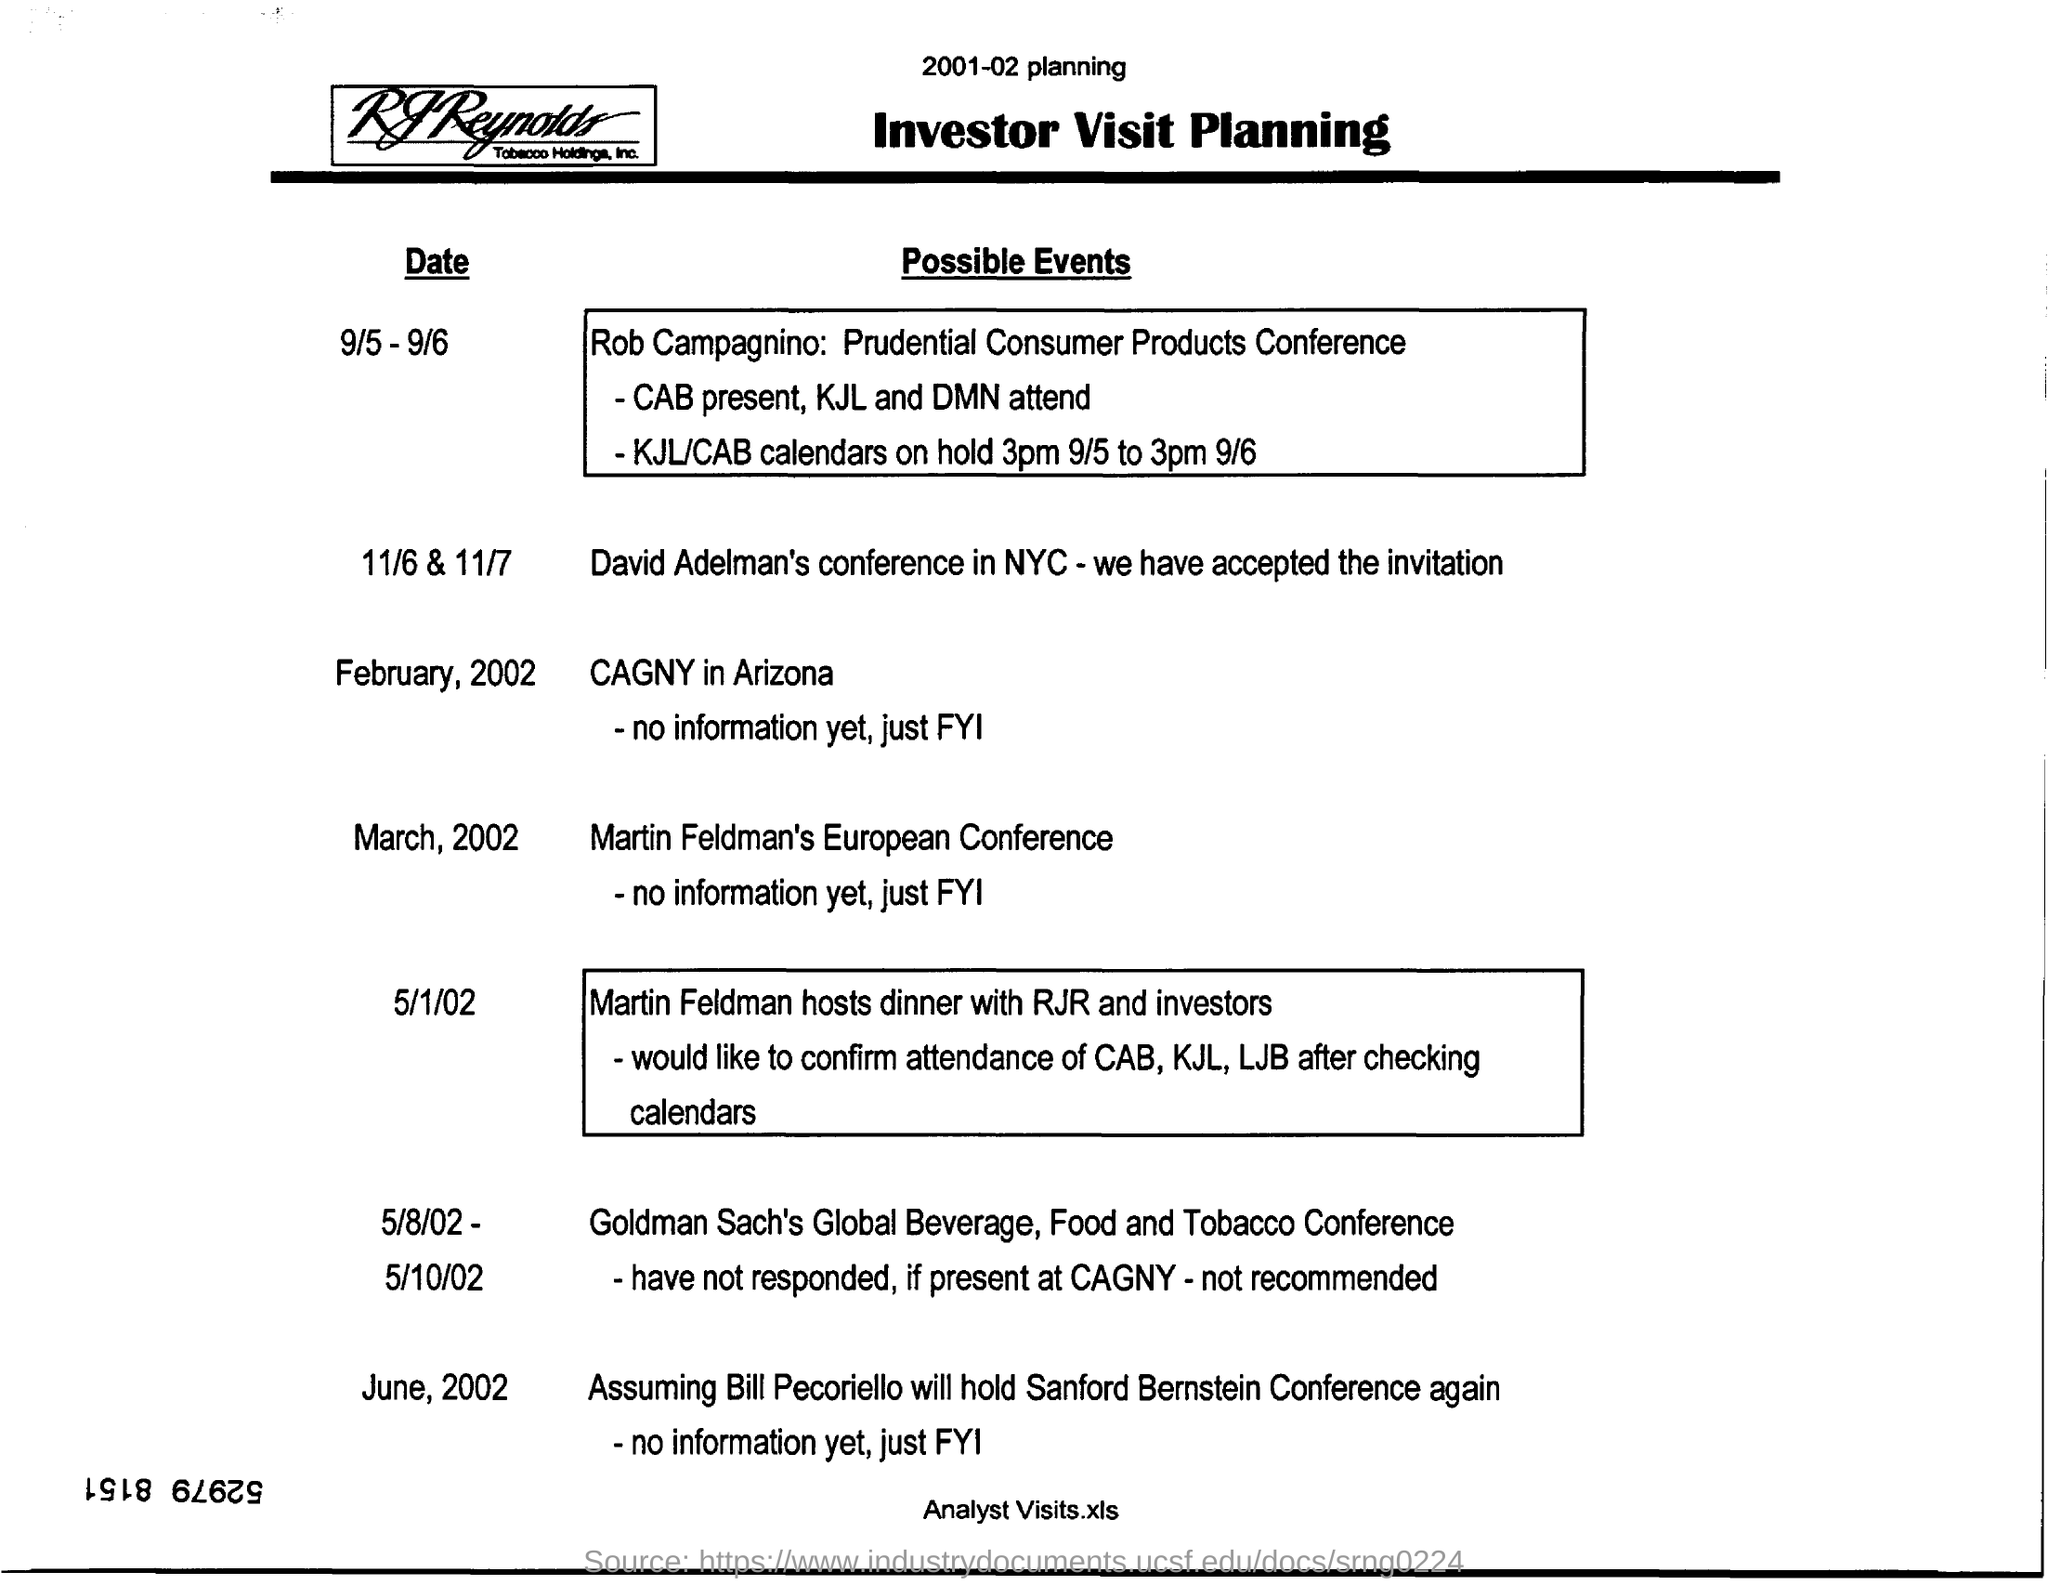List a handful of essential elements in this visual. David Adelman's conference in New York City was held on November 6th and 7th. On March 2002, Martin Feldman's European Conference was held. On May 8th, 2002, the Goldman Sach's Global Beverage, Food and Tobacco Conference was held. 